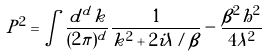<formula> <loc_0><loc_0><loc_500><loc_500>P ^ { 2 } = \int \frac { d ^ { d } k } { ( 2 \pi ) ^ { d } } \frac { 1 } { k ^ { 2 } + 2 i \lambda / \beta } - \frac { \beta ^ { 2 } h ^ { 2 } } { 4 \lambda ^ { 2 } }</formula> 